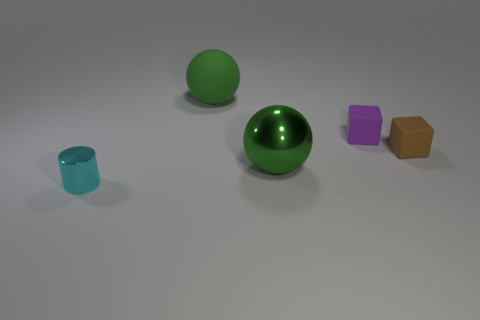Add 3 tiny gray matte balls. How many objects exist? 8 Subtract all blue balls. Subtract all gray cylinders. How many balls are left? 2 Subtract all cyan balls. How many purple cubes are left? 1 Add 3 big green shiny objects. How many big green shiny objects exist? 4 Subtract 0 green cylinders. How many objects are left? 5 Subtract all spheres. How many objects are left? 3 Subtract 1 cylinders. How many cylinders are left? 0 Subtract all big gray matte things. Subtract all big green metal objects. How many objects are left? 4 Add 4 small cyan things. How many small cyan things are left? 5 